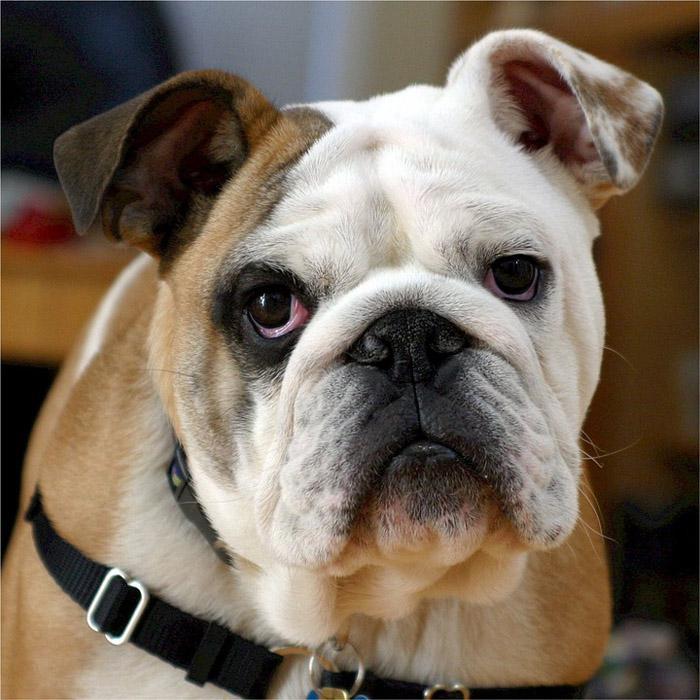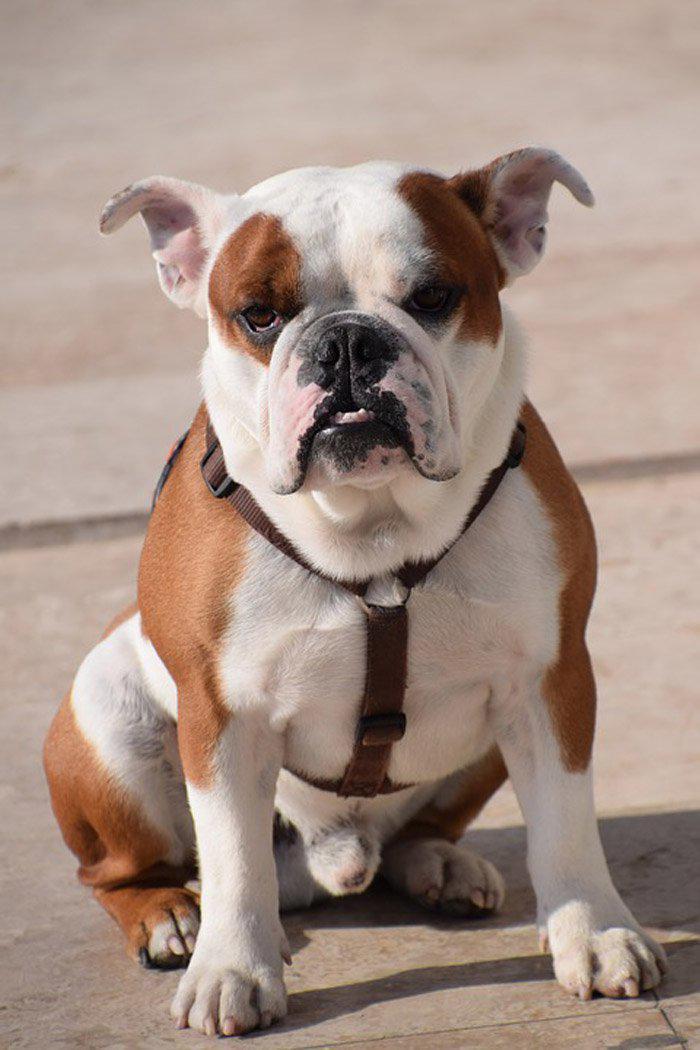The first image is the image on the left, the second image is the image on the right. Considering the images on both sides, is "The right image contains exactly three bulldogs." valid? Answer yes or no. No. The first image is the image on the left, the second image is the image on the right. Examine the images to the left and right. Is the description "There are exactly three bulldogs in each image" accurate? Answer yes or no. No. 